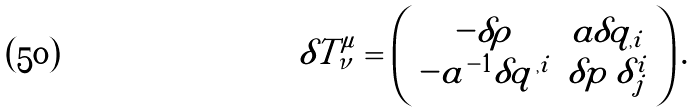Convert formula to latex. <formula><loc_0><loc_0><loc_500><loc_500>\delta T ^ { \mu } _ { \nu } = \left ( \begin{array} { c c } - \delta \rho & a \delta q _ { , i } \\ - a ^ { - 1 } \delta q ^ { , i } & \delta p \, \delta ^ { i } _ { \, j } \\ \end{array} \right ) .</formula> 